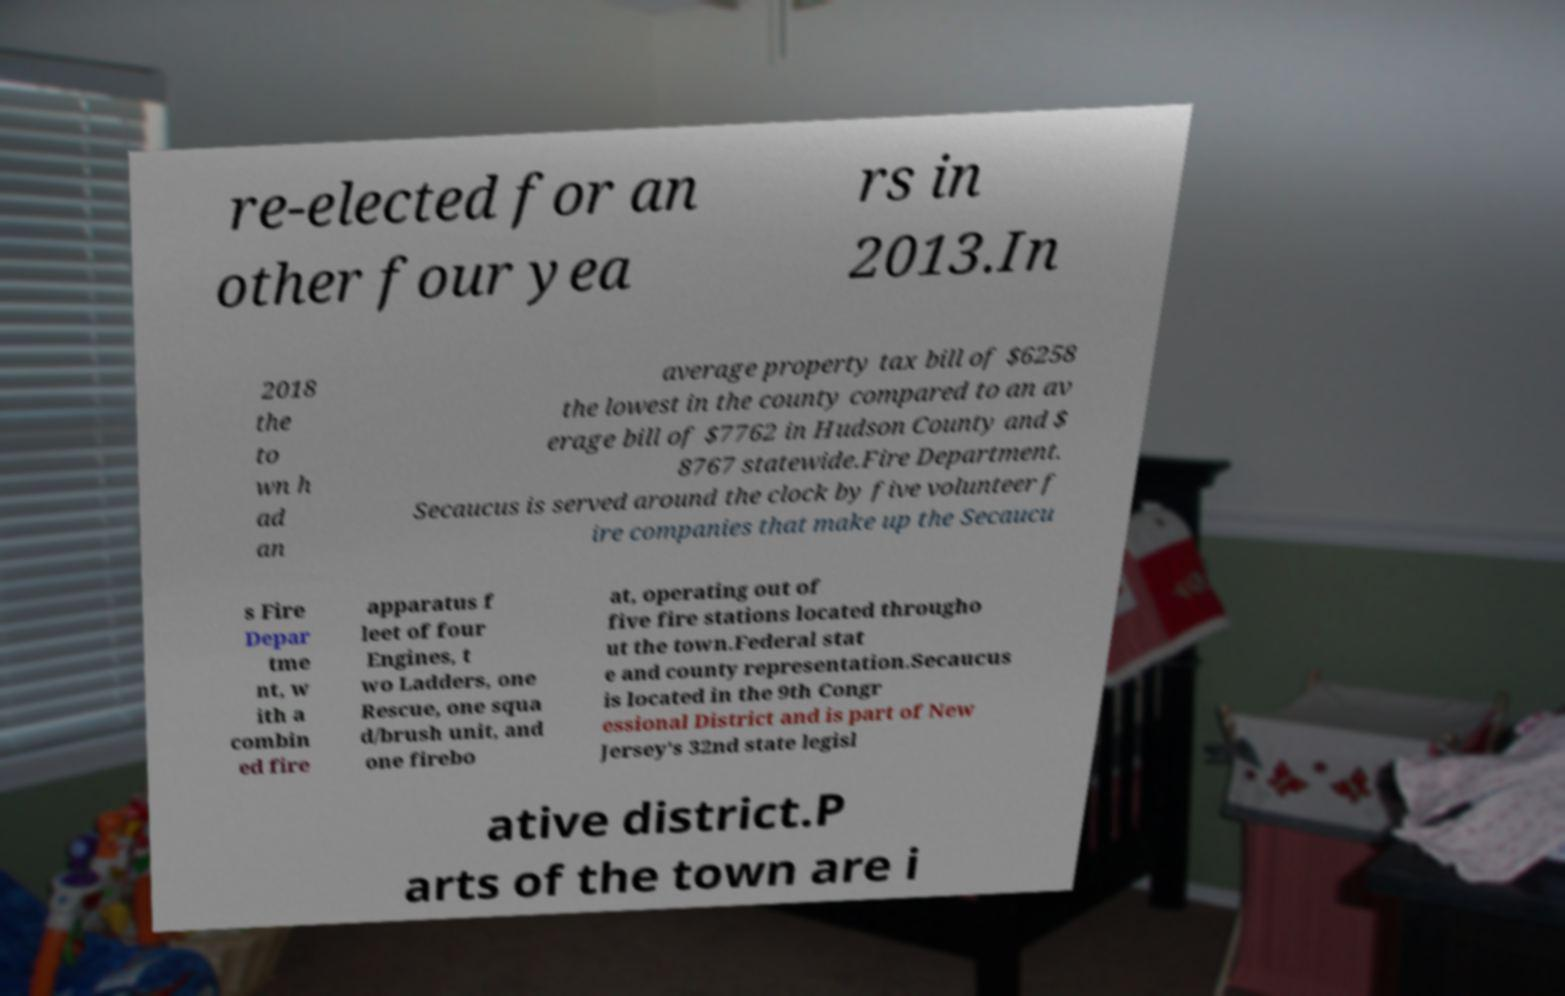Could you assist in decoding the text presented in this image and type it out clearly? re-elected for an other four yea rs in 2013.In 2018 the to wn h ad an average property tax bill of $6258 the lowest in the county compared to an av erage bill of $7762 in Hudson County and $ 8767 statewide.Fire Department. Secaucus is served around the clock by five volunteer f ire companies that make up the Secaucu s Fire Depar tme nt, w ith a combin ed fire apparatus f leet of four Engines, t wo Ladders, one Rescue, one squa d/brush unit, and one firebo at, operating out of five fire stations located througho ut the town.Federal stat e and county representation.Secaucus is located in the 9th Congr essional District and is part of New Jersey's 32nd state legisl ative district.P arts of the town are i 